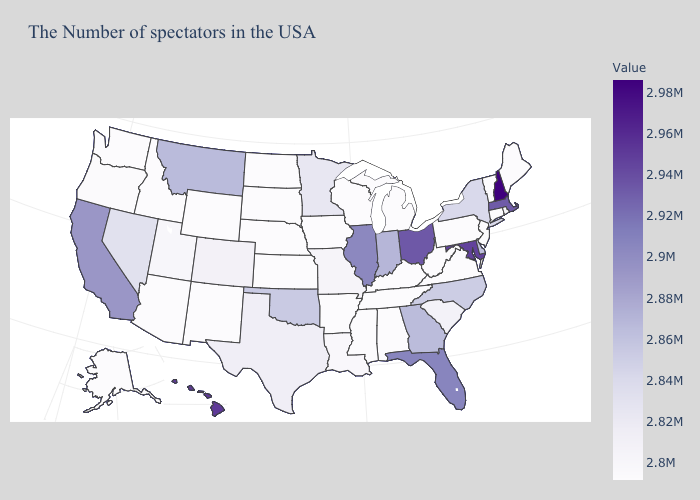Which states hav the highest value in the MidWest?
Short answer required. Ohio. Among the states that border North Carolina , does Georgia have the highest value?
Short answer required. Yes. Among the states that border Nevada , does Utah have the lowest value?
Answer briefly. No. 